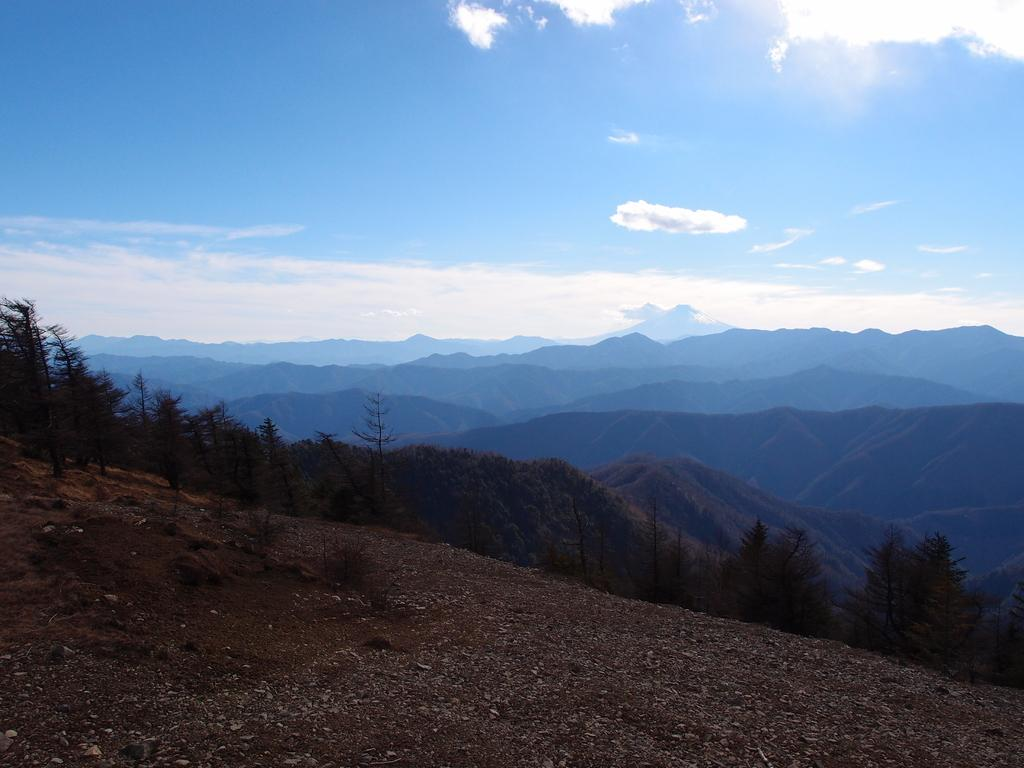What can be seen in the middle of the image? There are trees and mountains in the middle of the image. What is visible at the top of the image? The sky is visible at the top of the image. What type of wine is being served in the image? There is no wine present in the image; it features trees, mountains, and the sky. Is there a pocket visible in the image? There is no pocket visible in the image. 